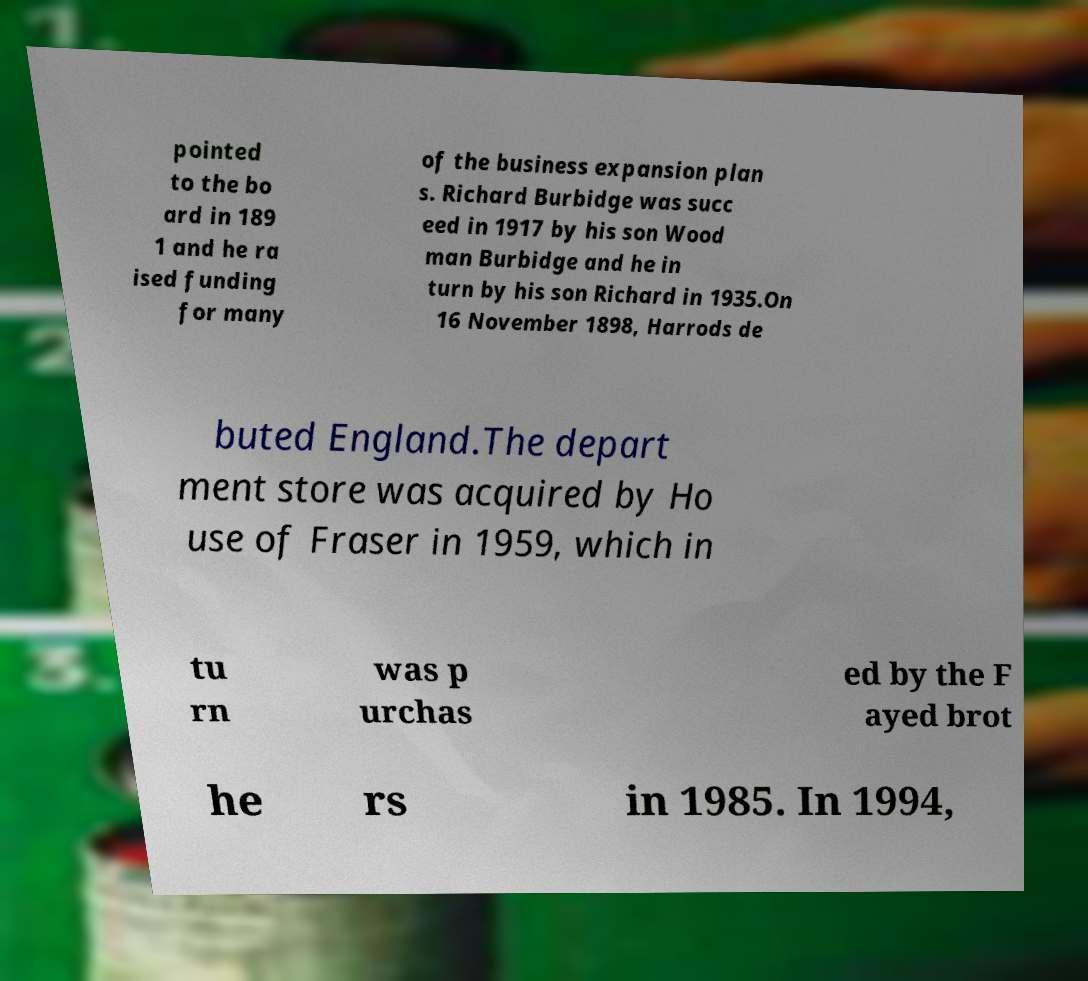I need the written content from this picture converted into text. Can you do that? pointed to the bo ard in 189 1 and he ra ised funding for many of the business expansion plan s. Richard Burbidge was succ eed in 1917 by his son Wood man Burbidge and he in turn by his son Richard in 1935.On 16 November 1898, Harrods de buted England.The depart ment store was acquired by Ho use of Fraser in 1959, which in tu rn was p urchas ed by the F ayed brot he rs in 1985. In 1994, 